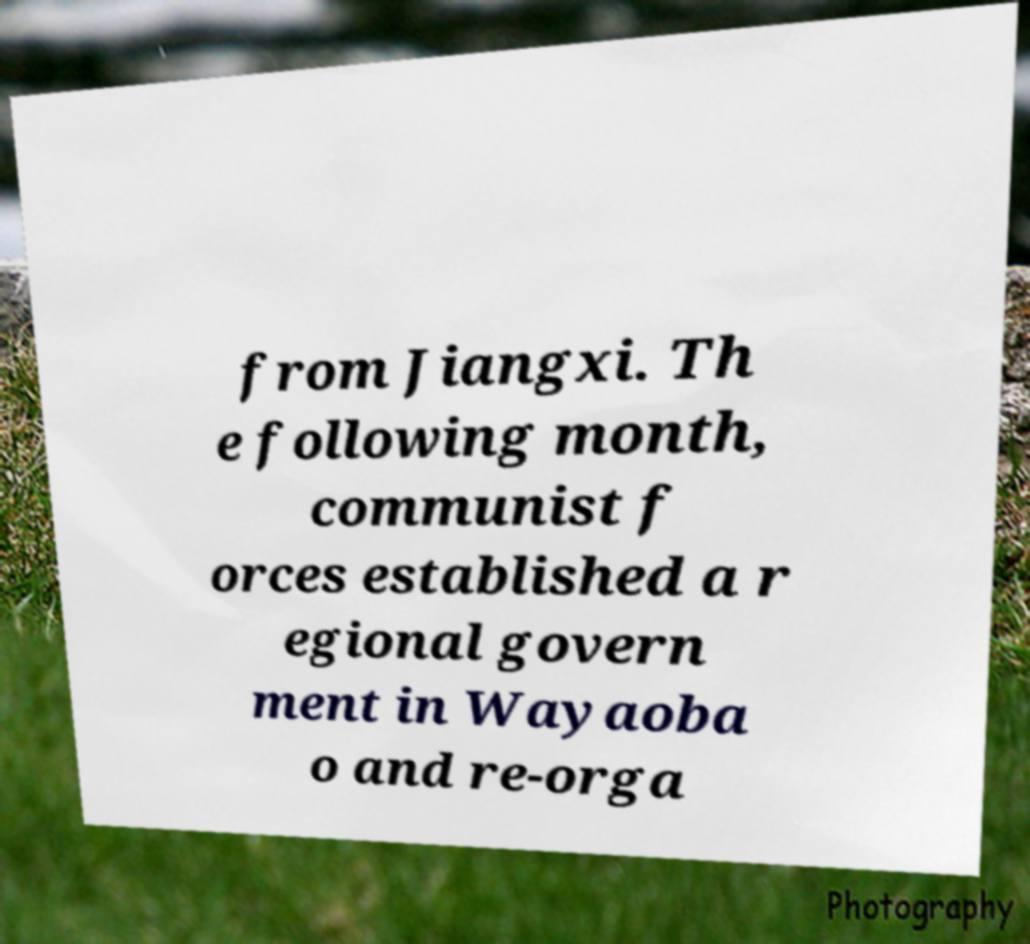There's text embedded in this image that I need extracted. Can you transcribe it verbatim? from Jiangxi. Th e following month, communist f orces established a r egional govern ment in Wayaoba o and re-orga 